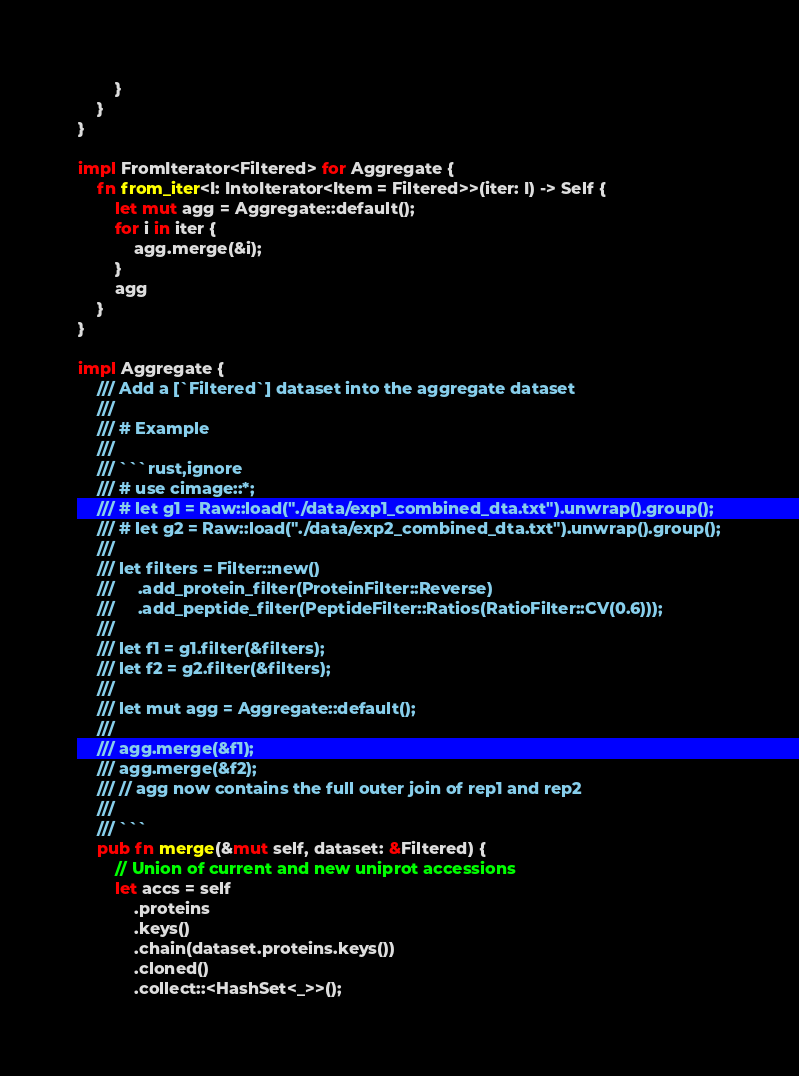<code> <loc_0><loc_0><loc_500><loc_500><_Rust_>        }
    }
}

impl FromIterator<Filtered> for Aggregate {
    fn from_iter<I: IntoIterator<Item = Filtered>>(iter: I) -> Self {
        let mut agg = Aggregate::default();
        for i in iter {
            agg.merge(&i);
        }
        agg
    }
}

impl Aggregate {
    /// Add a [`Filtered`] dataset into the aggregate dataset
    ///
    /// # Example
    ///
    /// ```rust,ignore
    /// # use cimage::*;
    /// # let g1 = Raw::load("./data/exp1_combined_dta.txt").unwrap().group();
    /// # let g2 = Raw::load("./data/exp2_combined_dta.txt").unwrap().group();
    ///
    /// let filters = Filter::new()
    ///     .add_protein_filter(ProteinFilter::Reverse)
    ///     .add_peptide_filter(PeptideFilter::Ratios(RatioFilter::CV(0.6)));
    ///
    /// let f1 = g1.filter(&filters);
    /// let f2 = g2.filter(&filters);
    ///
    /// let mut agg = Aggregate::default();
    ///
    /// agg.merge(&f1);
    /// agg.merge(&f2);
    /// // agg now contains the full outer join of rep1 and rep2
    ///
    /// ```
    pub fn merge(&mut self, dataset: &Filtered) {
        // Union of current and new uniprot accessions
        let accs = self
            .proteins
            .keys()
            .chain(dataset.proteins.keys())
            .cloned()
            .collect::<HashSet<_>>();
</code> 